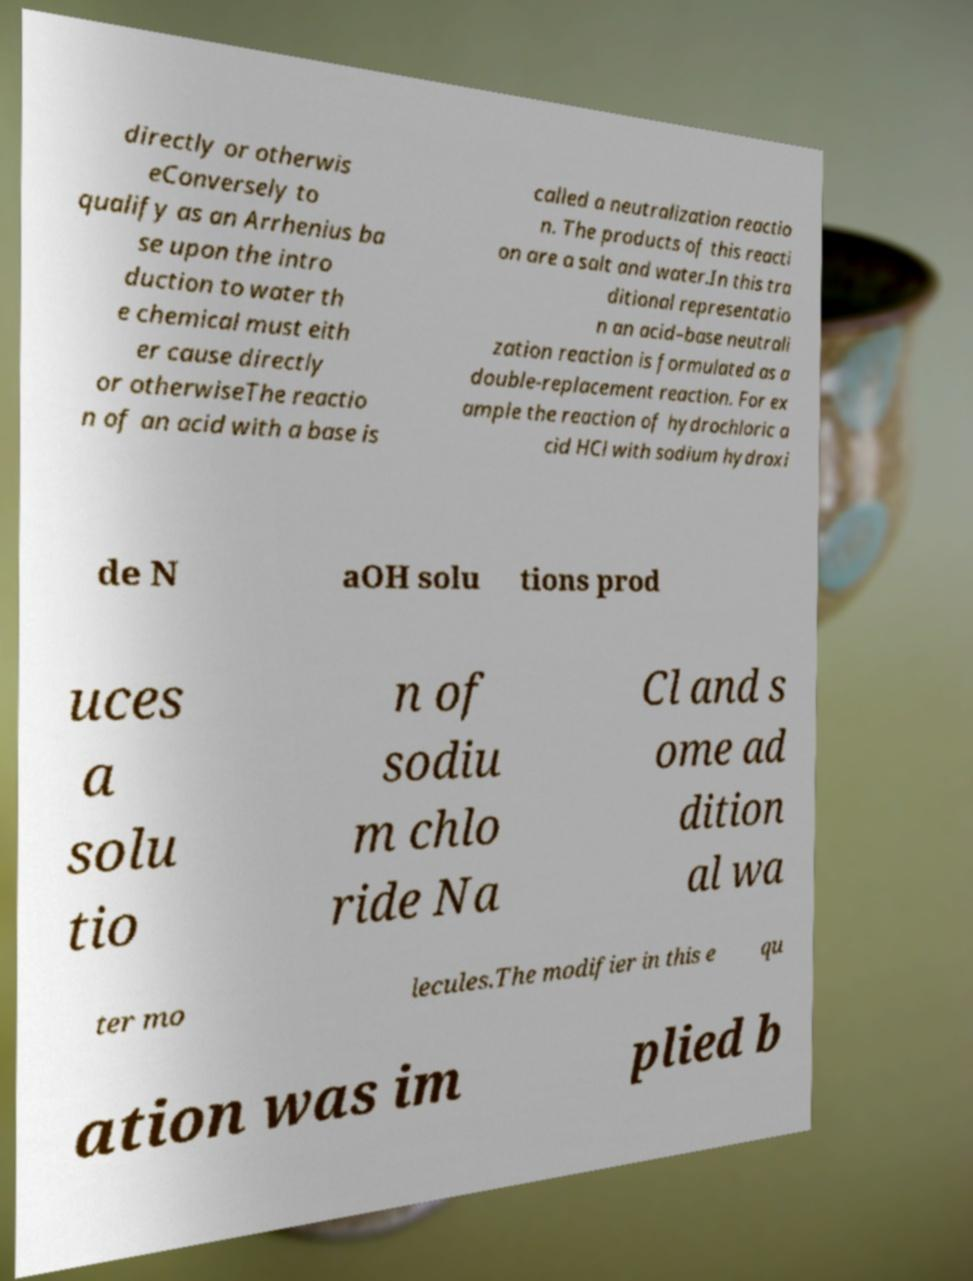Can you accurately transcribe the text from the provided image for me? directly or otherwis eConversely to qualify as an Arrhenius ba se upon the intro duction to water th e chemical must eith er cause directly or otherwiseThe reactio n of an acid with a base is called a neutralization reactio n. The products of this reacti on are a salt and water.In this tra ditional representatio n an acid–base neutrali zation reaction is formulated as a double-replacement reaction. For ex ample the reaction of hydrochloric a cid HCl with sodium hydroxi de N aOH solu tions prod uces a solu tio n of sodiu m chlo ride Na Cl and s ome ad dition al wa ter mo lecules.The modifier in this e qu ation was im plied b 